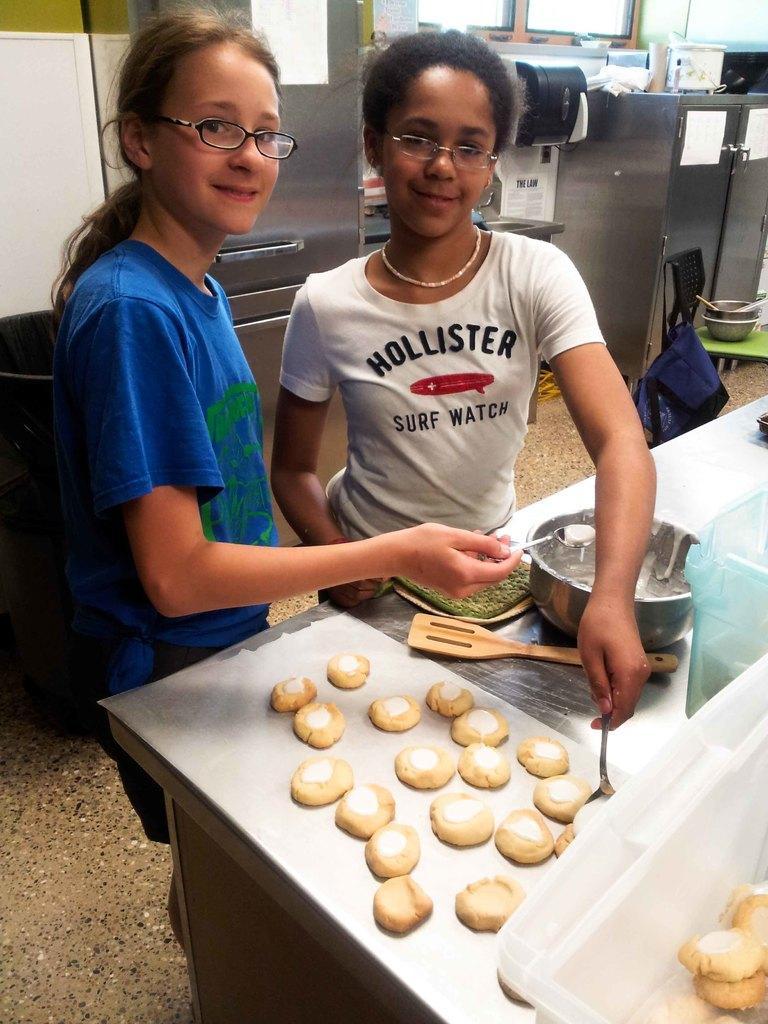How would you summarize this image in a sentence or two? In this image we can see two children holding the spoons standing beside a table containing some biscuits, spatula and a bowl on it. On the backside we can see a container, an oven and a chair. 